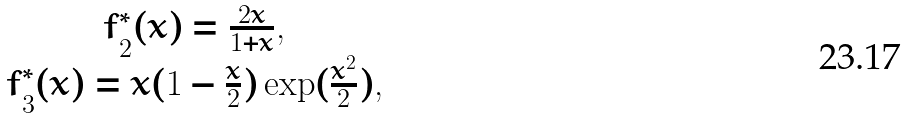Convert formula to latex. <formula><loc_0><loc_0><loc_500><loc_500>\begin{array} { c } f _ { 2 } ^ { * } ( x ) = \frac { 2 x } { 1 + x } , \\ f _ { 3 } ^ { * } ( x ) = x ( 1 - \frac { x } { 2 } ) \exp ( \frac { x ^ { 2 } } 2 ) , \end{array}</formula> 